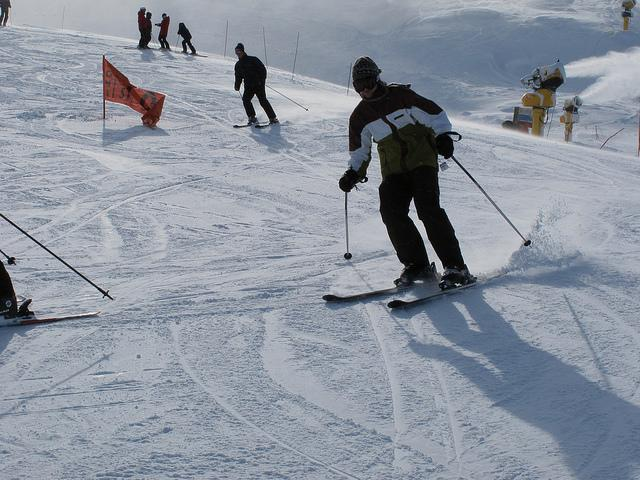What is this activity for? Please explain your reasoning. racing. Flags placed on a skiing trail is usually intending to mark a path that one must take in a race. 